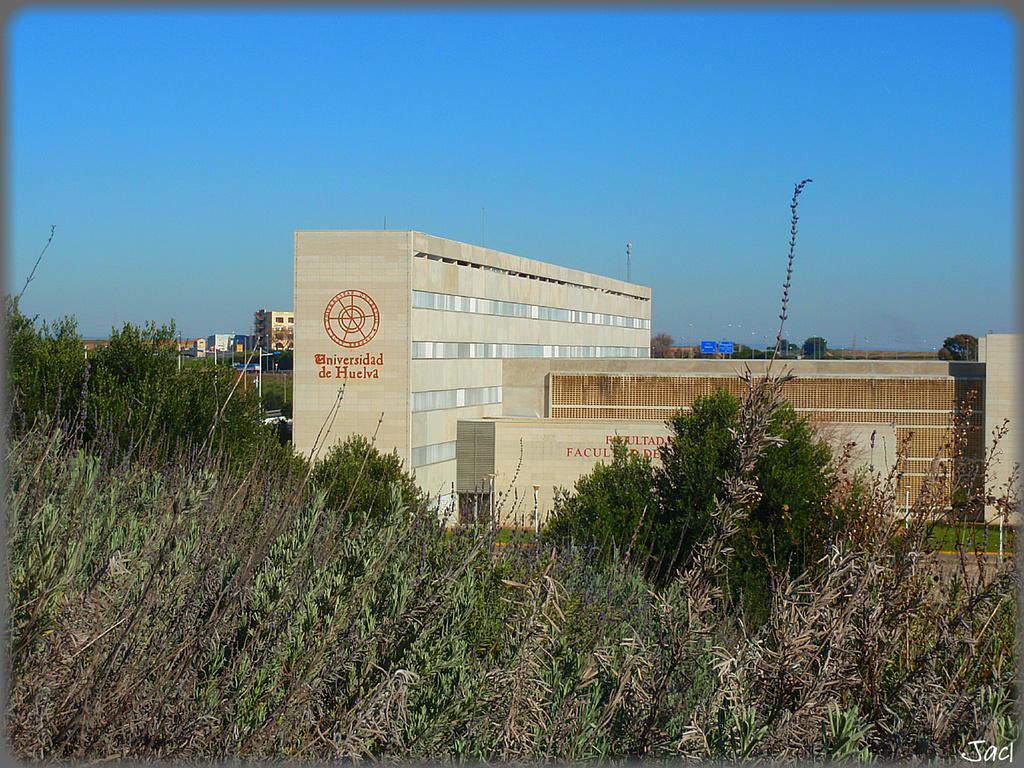How would you summarize this image in a sentence or two? In this image I can see a building in cream color, trees in green color. Background I can see few other buildings and the sky is in blue color. 